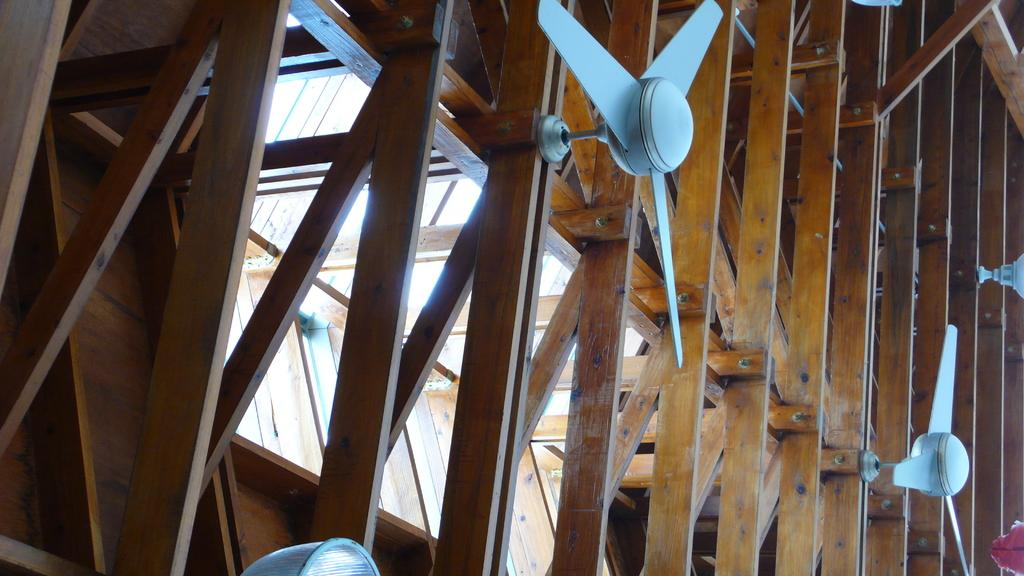What type of material is used for the ceiling in the image? There is a wooden ceiling in the image. What can be seen hanging from the wooden ceiling? There are fans and lights on the wooden ceiling. How many snakes are slithering on the wooden ceiling in the image? There are no snakes present in the image; it only features a wooden ceiling with fans and lights. 